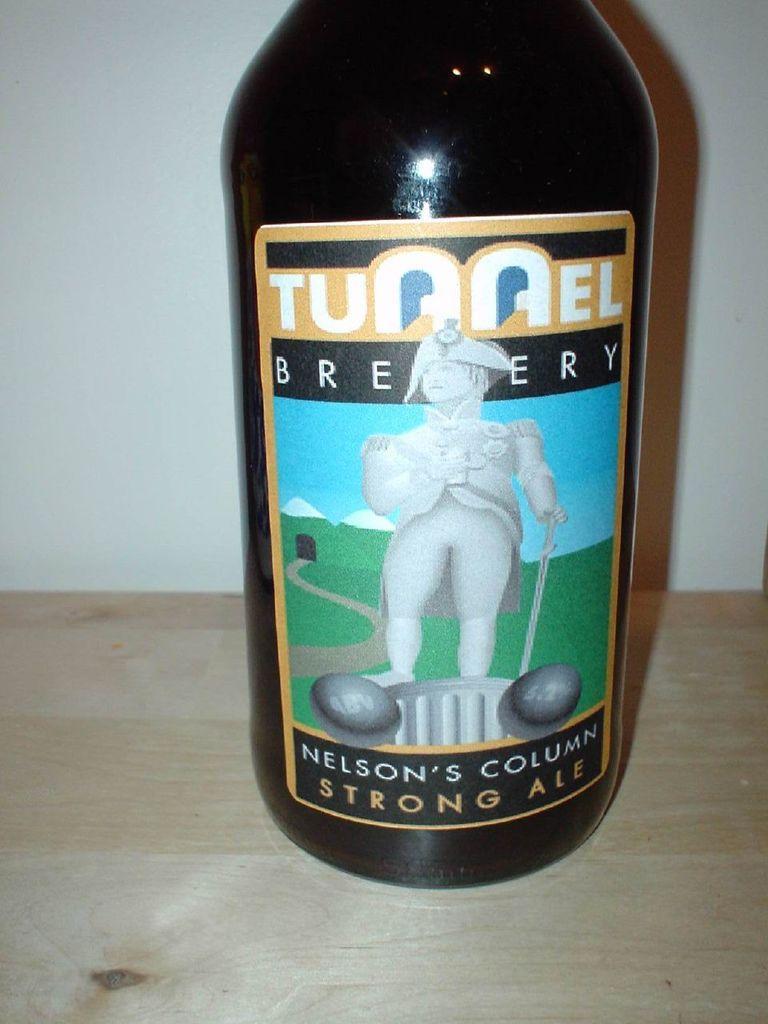Could you give a brief overview of what you see in this image? In this image we can see a bottle with the picture and some text on it which is placed on the surface. On the backside we can see a wall. 